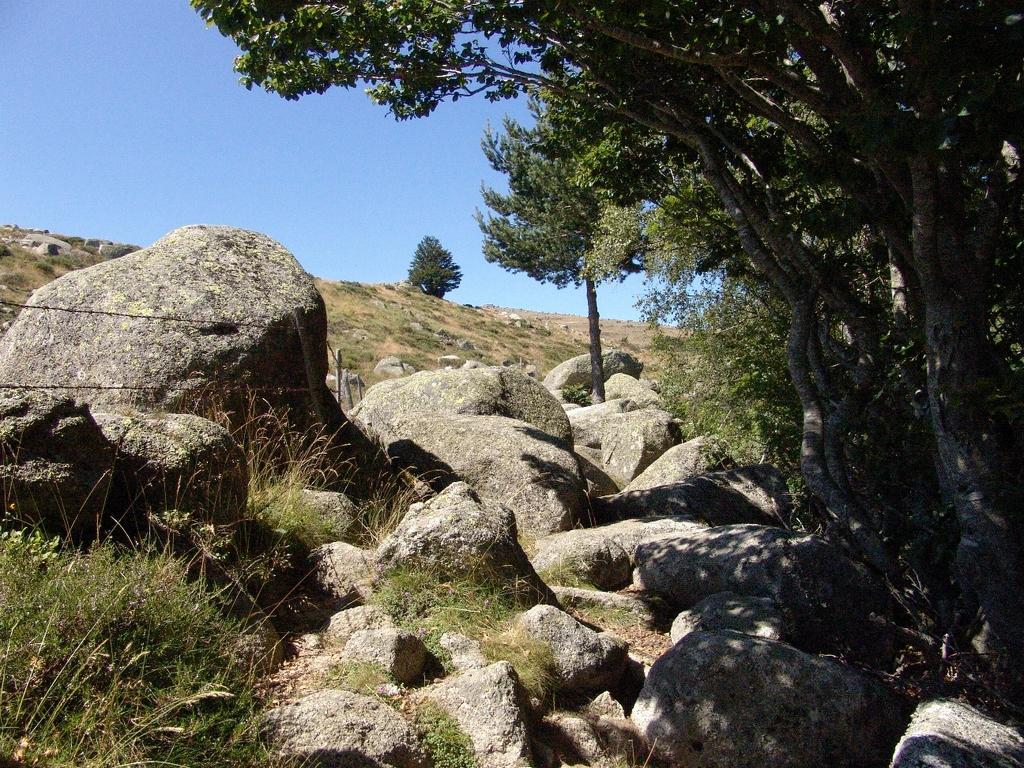Can you describe this image briefly? In this image on the right side there are some trees, at the bottom there is grass and some rocks. On the top of the image there is sky. 